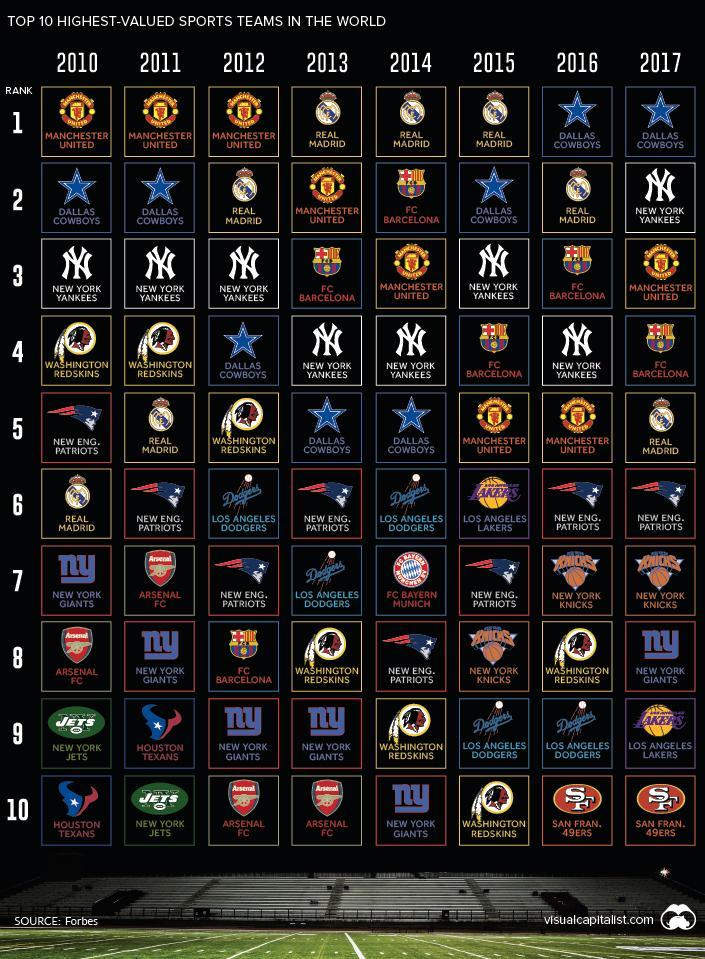Which was the team that ranked tenth consecutively after 2014?
Answer the question with a short phrase. SAN FRAN.49ERS Which team is placed in the sixth column and eighth row ? NEW YORK KNICKS What was the ranking of Man U in the 2015 and 2016? 5 Which year was the lowest recorded ranking of FCB? 2012 How many times did the Dallas Cowboys rank in the number 1 position consecutively? 2 Which team was placed in the fifth row in the year 2012? WASHINGTON REDSKINS Which teams  ranked number consecutively for three years? MANCHESTER UNITED, REAL MADRID Which team dropped from the second position to the fourth rank in 2015? FC BARCELONA In which year was FCB placed in the second position? 2014 